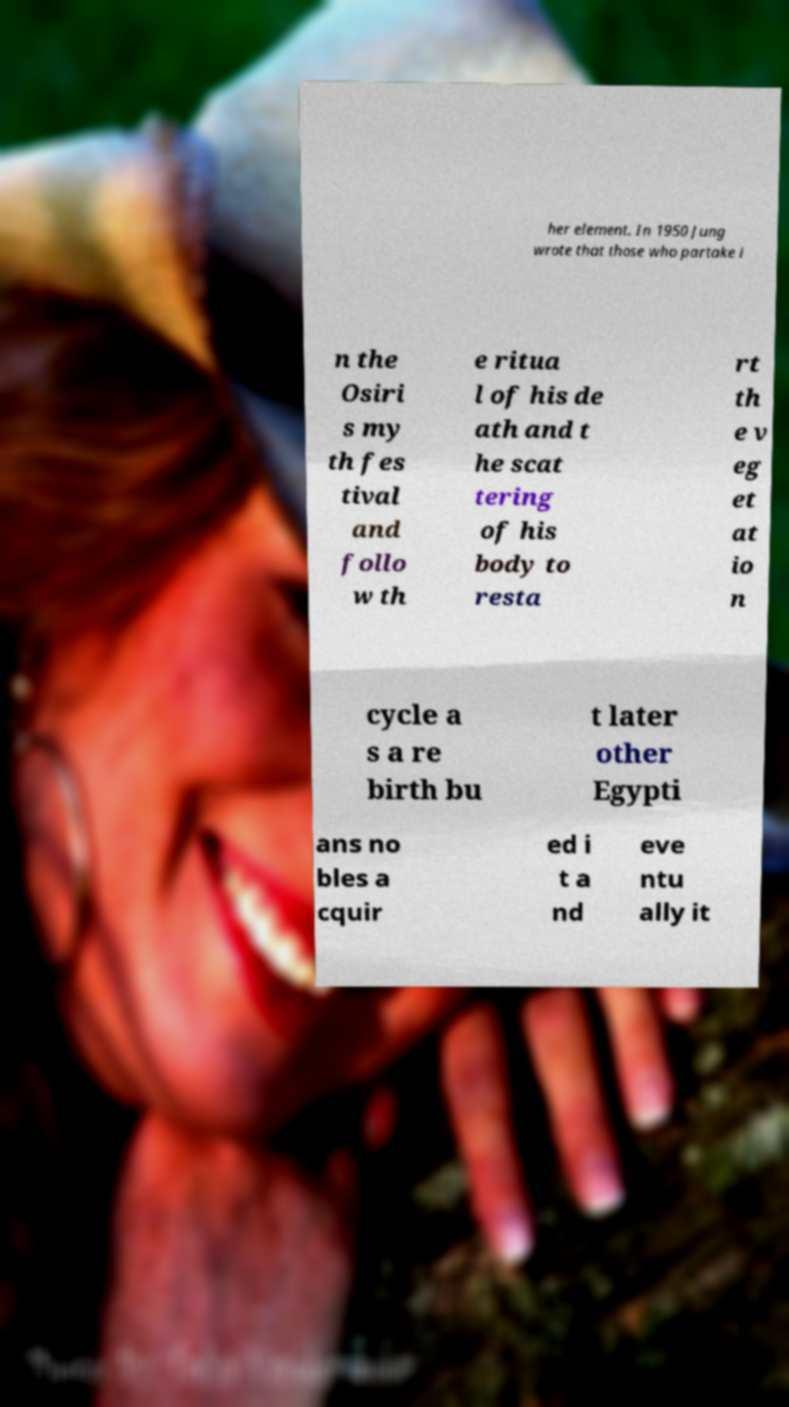I need the written content from this picture converted into text. Can you do that? her element. In 1950 Jung wrote that those who partake i n the Osiri s my th fes tival and follo w th e ritua l of his de ath and t he scat tering of his body to resta rt th e v eg et at io n cycle a s a re birth bu t later other Egypti ans no bles a cquir ed i t a nd eve ntu ally it 